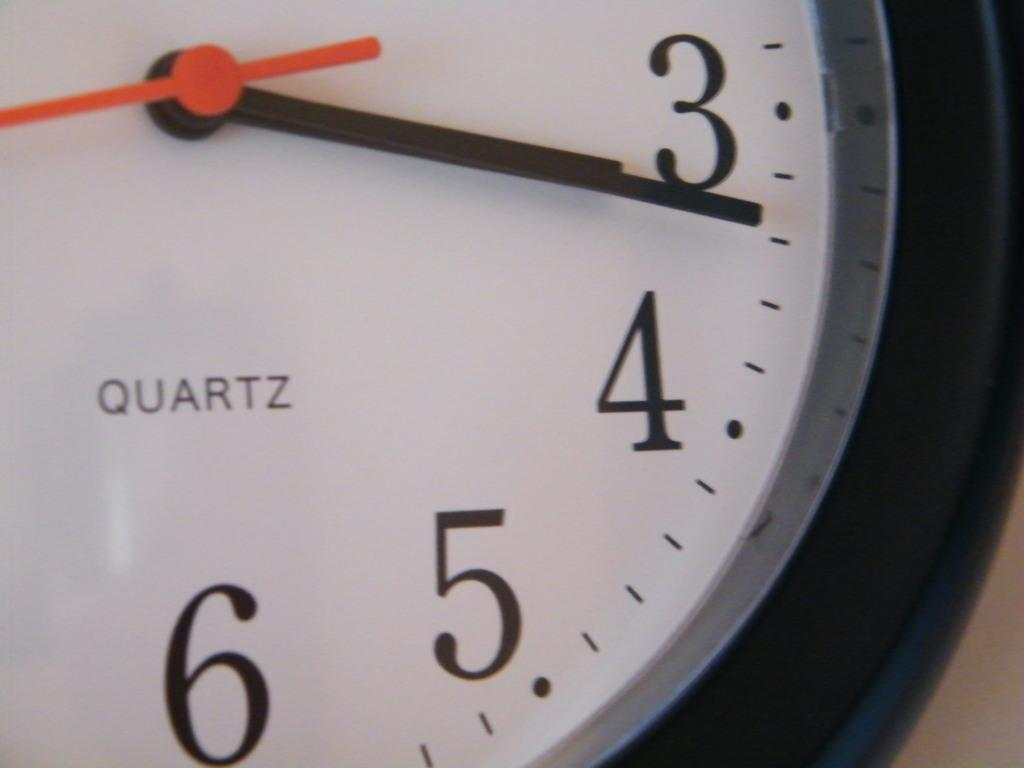<image>
Render a clear and concise summary of the photo. A clock with "QUARTZ" printed on it has the time of 3:16. 